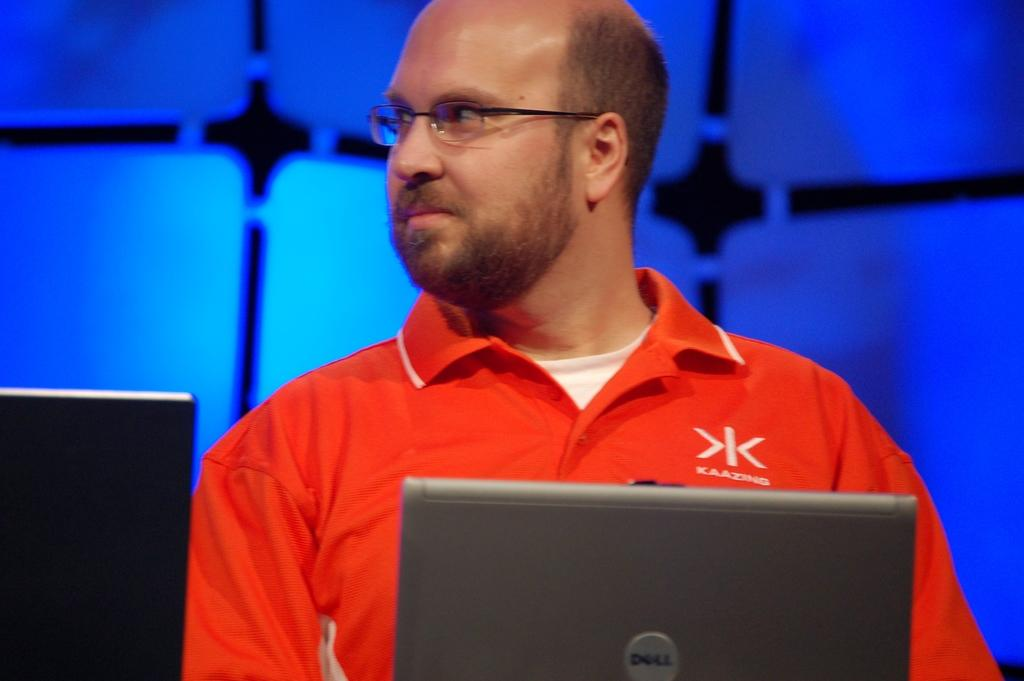Who or what is the main subject in the image? There is a person in the image. What is the person wearing? The person is wearing an orange t-shirt. Where is the person located in the image? The person is in the center of the image. What electronic device can be seen at the bottom of the image? There is a laptop at the bottom of the image. What type of insect can be seen crawling on the person's orange t-shirt in the image? There is no insect visible on the person's orange t-shirt in the image. 